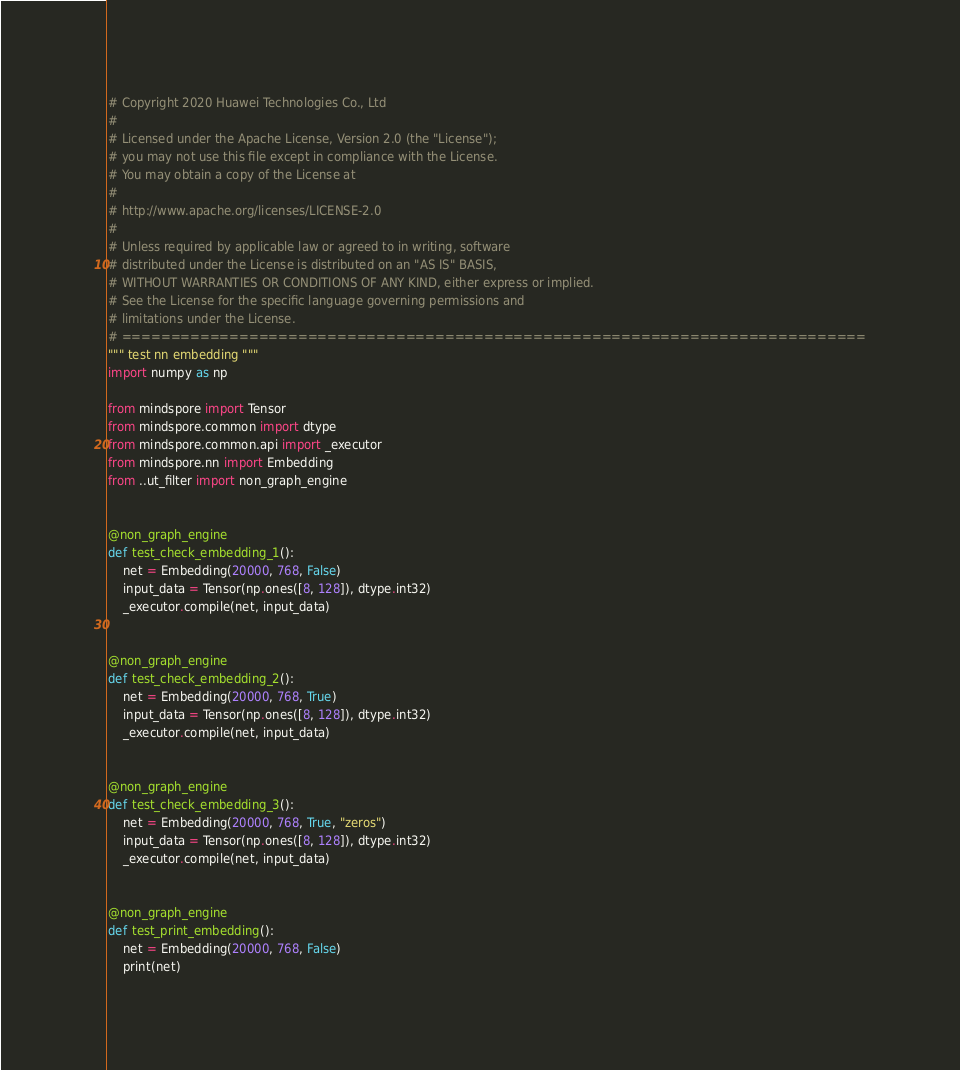<code> <loc_0><loc_0><loc_500><loc_500><_Python_># Copyright 2020 Huawei Technologies Co., Ltd
#
# Licensed under the Apache License, Version 2.0 (the "License");
# you may not use this file except in compliance with the License.
# You may obtain a copy of the License at
#
# http://www.apache.org/licenses/LICENSE-2.0
#
# Unless required by applicable law or agreed to in writing, software
# distributed under the License is distributed on an "AS IS" BASIS,
# WITHOUT WARRANTIES OR CONDITIONS OF ANY KIND, either express or implied.
# See the License for the specific language governing permissions and
# limitations under the License.
# ============================================================================
""" test nn embedding """
import numpy as np

from mindspore import Tensor
from mindspore.common import dtype
from mindspore.common.api import _executor
from mindspore.nn import Embedding
from ..ut_filter import non_graph_engine


@non_graph_engine
def test_check_embedding_1():
    net = Embedding(20000, 768, False)
    input_data = Tensor(np.ones([8, 128]), dtype.int32)
    _executor.compile(net, input_data)


@non_graph_engine
def test_check_embedding_2():
    net = Embedding(20000, 768, True)
    input_data = Tensor(np.ones([8, 128]), dtype.int32)
    _executor.compile(net, input_data)


@non_graph_engine
def test_check_embedding_3():
    net = Embedding(20000, 768, True, "zeros")
    input_data = Tensor(np.ones([8, 128]), dtype.int32)
    _executor.compile(net, input_data)


@non_graph_engine
def test_print_embedding():
    net = Embedding(20000, 768, False)
    print(net)
</code> 